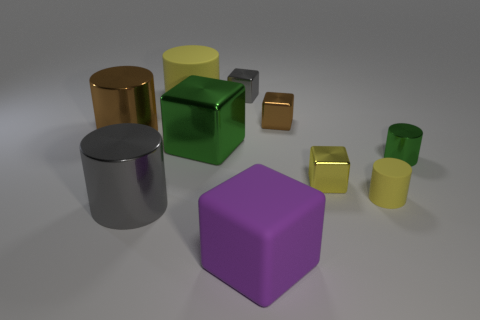Are there fewer tiny gray shiny cubes that are behind the small brown metal block than purple cubes?
Provide a short and direct response. No. Do the small yellow block and the big cube in front of the big gray thing have the same material?
Ensure brevity in your answer.  No. There is a yellow rubber object that is on the right side of the small thing to the left of the matte cube; are there any small green shiny cylinders that are behind it?
Provide a short and direct response. Yes. Is there any other thing that is the same size as the purple cube?
Make the answer very short. Yes. There is a small cylinder that is made of the same material as the big green thing; what color is it?
Provide a short and direct response. Green. How big is the thing that is in front of the tiny yellow cylinder and on the left side of the big yellow cylinder?
Keep it short and to the point. Large. Are there fewer big green things that are in front of the brown metallic block than tiny brown things in front of the large brown shiny object?
Your answer should be compact. No. Do the brown object to the right of the big yellow rubber thing and the yellow cylinder that is on the right side of the big yellow cylinder have the same material?
Provide a short and direct response. No. What is the material of the small cube that is the same color as the small rubber cylinder?
Provide a succinct answer. Metal. There is a small metallic object that is both in front of the large yellow thing and behind the green shiny block; what shape is it?
Keep it short and to the point. Cube. 